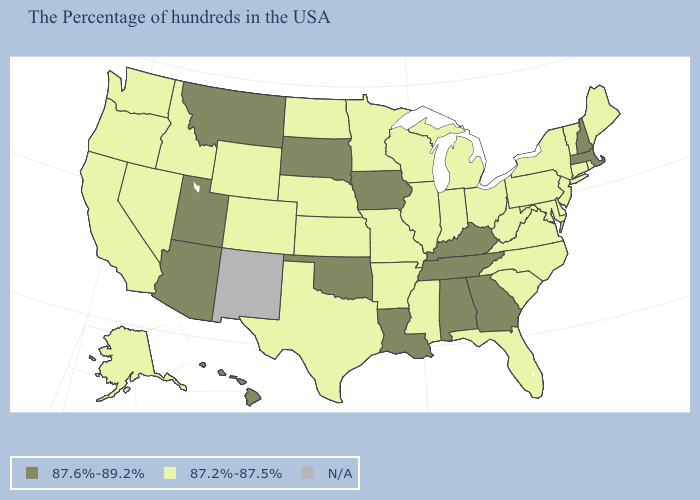What is the lowest value in states that border Montana?
Answer briefly. 87.2%-87.5%. Which states hav the highest value in the Northeast?
Keep it brief. Massachusetts, New Hampshire. What is the value of Utah?
Quick response, please. 87.6%-89.2%. Is the legend a continuous bar?
Give a very brief answer. No. What is the value of Montana?
Answer briefly. 87.6%-89.2%. What is the value of Utah?
Quick response, please. 87.6%-89.2%. What is the value of Mississippi?
Keep it brief. 87.2%-87.5%. Which states have the lowest value in the USA?
Quick response, please. Maine, Rhode Island, Vermont, Connecticut, New York, New Jersey, Delaware, Maryland, Pennsylvania, Virginia, North Carolina, South Carolina, West Virginia, Ohio, Florida, Michigan, Indiana, Wisconsin, Illinois, Mississippi, Missouri, Arkansas, Minnesota, Kansas, Nebraska, Texas, North Dakota, Wyoming, Colorado, Idaho, Nevada, California, Washington, Oregon, Alaska. Which states have the lowest value in the USA?
Answer briefly. Maine, Rhode Island, Vermont, Connecticut, New York, New Jersey, Delaware, Maryland, Pennsylvania, Virginia, North Carolina, South Carolina, West Virginia, Ohio, Florida, Michigan, Indiana, Wisconsin, Illinois, Mississippi, Missouri, Arkansas, Minnesota, Kansas, Nebraska, Texas, North Dakota, Wyoming, Colorado, Idaho, Nevada, California, Washington, Oregon, Alaska. Does Alaska have the highest value in the USA?
Be succinct. No. How many symbols are there in the legend?
Answer briefly. 3. Does the map have missing data?
Write a very short answer. Yes. What is the value of Connecticut?
Quick response, please. 87.2%-87.5%. What is the value of Mississippi?
Short answer required. 87.2%-87.5%. Does Utah have the lowest value in the USA?
Be succinct. No. 